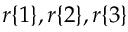<formula> <loc_0><loc_0><loc_500><loc_500>r \{ 1 \} , r \{ 2 \} , r \{ 3 \}</formula> 